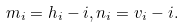<formula> <loc_0><loc_0><loc_500><loc_500>m _ { i } = h _ { i } - i , n _ { i } = v _ { i } - i .</formula> 